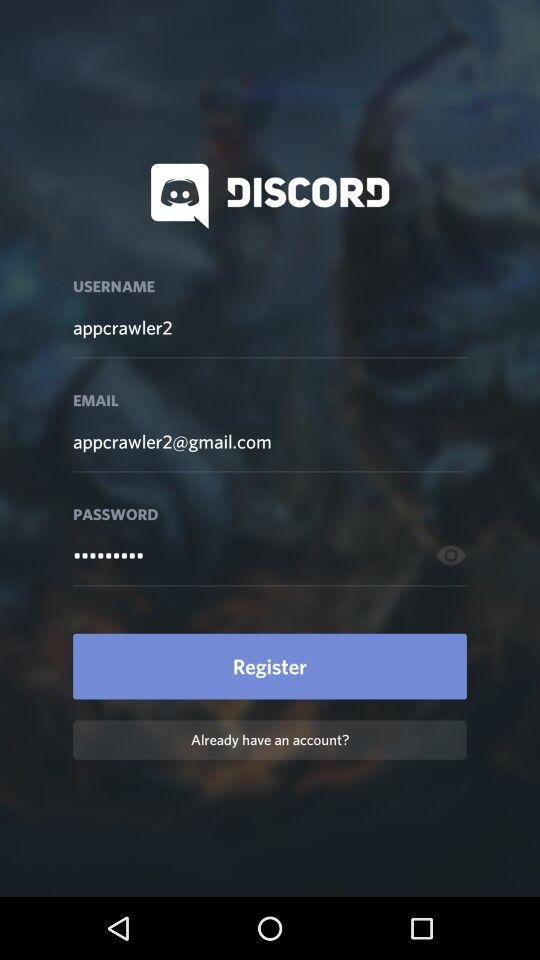What is the given Gmail address? The given Gmail address is appcrawler2@gmail.com. 